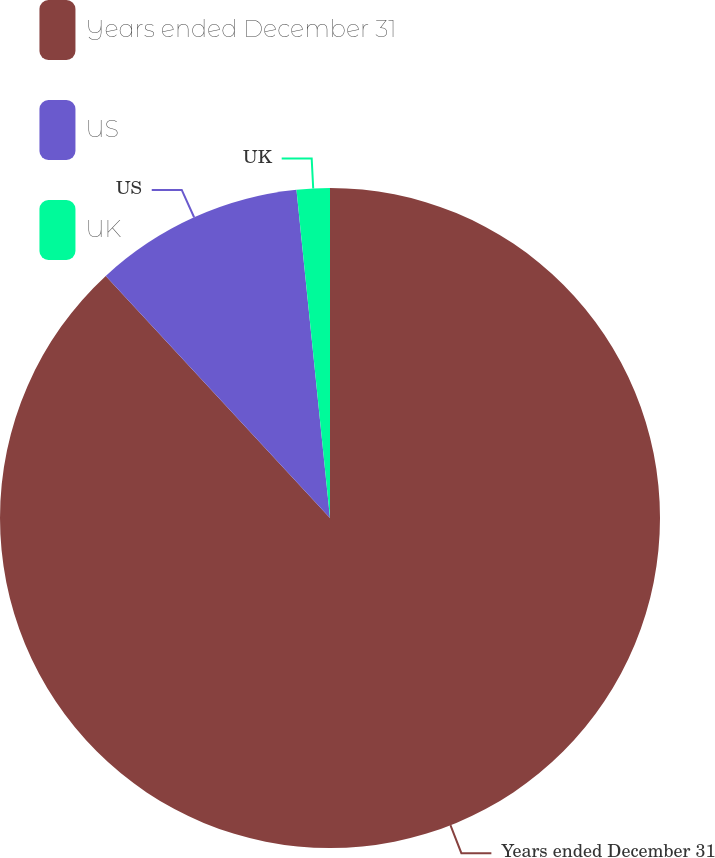Convert chart. <chart><loc_0><loc_0><loc_500><loc_500><pie_chart><fcel>Years ended December 31<fcel>US<fcel>UK<nl><fcel>88.1%<fcel>10.27%<fcel>1.62%<nl></chart> 